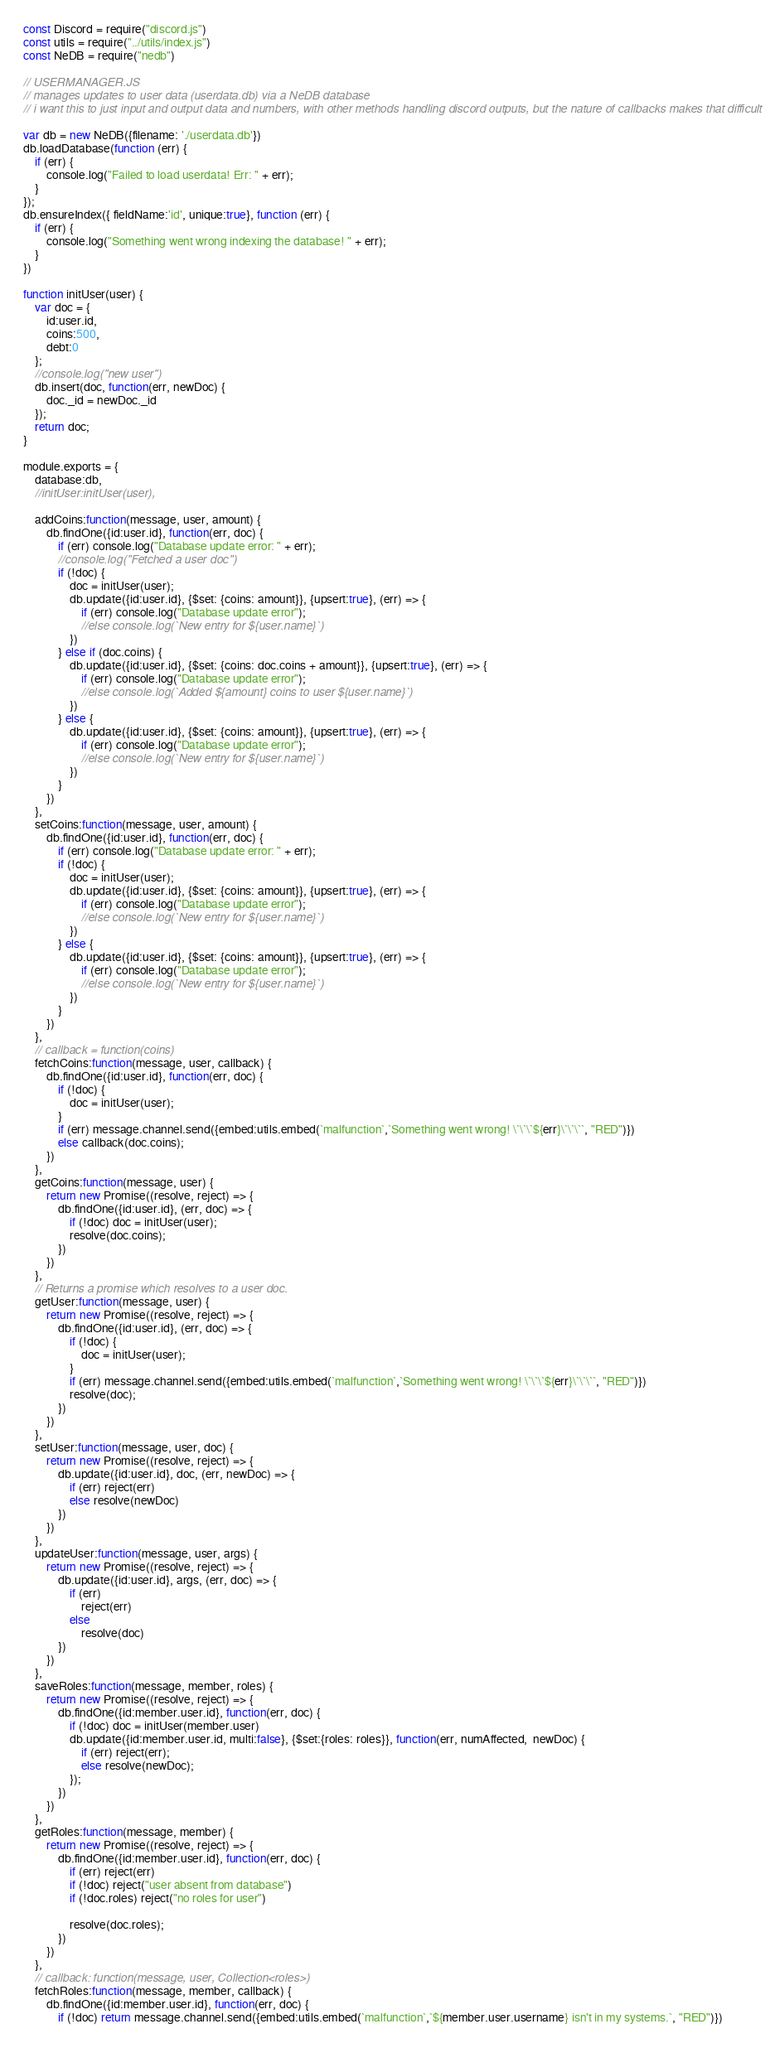Convert code to text. <code><loc_0><loc_0><loc_500><loc_500><_JavaScript_>const Discord = require("discord.js")
const utils = require("../utils/index.js")
const NeDB = require("nedb")

// USERMANAGER.JS
// manages updates to user data (userdata.db) via a NeDB database
// i want this to just input and output data and numbers, with other methods handling discord outputs, but the nature of callbacks makes that difficult

var db = new NeDB({filename: './userdata.db'})
db.loadDatabase(function (err) {
	if (err) {
		console.log("Failed to load userdata! Err: " + err);
	}
});
db.ensureIndex({ fieldName:'id', unique:true}, function (err) {
	if (err) {
		console.log("Something went wrong indexing the database! " + err);
	}
})

function initUser(user) {
	var doc = {
		id:user.id,
		coins:500,
		debt:0
	};
	//console.log("new user")
	db.insert(doc, function(err, newDoc) {
		doc._id = newDoc._id
	});
	return doc;
}

module.exports = {
	database:db,
	//initUser:initUser(user),

	addCoins:function(message, user, amount) {
		db.findOne({id:user.id}, function(err, doc) {
			if (err) console.log("Database update error: " + err);
			//console.log("Fetched a user doc")
			if (!doc) {
				doc = initUser(user);
				db.update({id:user.id}, {$set: {coins: amount}}, {upsert:true}, (err) => {
					if (err) console.log("Database update error");
					//else console.log(`New entry for ${user.name}`)
				})
			} else if (doc.coins) {
				db.update({id:user.id}, {$set: {coins: doc.coins + amount}}, {upsert:true}, (err) => {
					if (err) console.log("Database update error");
					//else console.log(`Added ${amount} coins to user ${user.name}`)
				})
			} else {
				db.update({id:user.id}, {$set: {coins: amount}}, {upsert:true}, (err) => {
					if (err) console.log("Database update error");
					//else console.log(`New entry for ${user.name}`)
				})
			}
		})
	},
	setCoins:function(message, user, amount) {
		db.findOne({id:user.id}, function(err, doc) {
			if (err) console.log("Database update error: " + err);
			if (!doc) {
				doc = initUser(user);
				db.update({id:user.id}, {$set: {coins: amount}}, {upsert:true}, (err) => {
					if (err) console.log("Database update error");
					//else console.log(`New entry for ${user.name}`)
				})
			} else {
				db.update({id:user.id}, {$set: {coins: amount}}, {upsert:true}, (err) => {
					if (err) console.log("Database update error");
					//else console.log(`New entry for ${user.name}`)
				})
			}
		})
	},
	// callback = function(coins)
	fetchCoins:function(message, user, callback) {
		db.findOne({id:user.id}, function(err, doc) {
			if (!doc) {
				doc = initUser(user);
			}
			if (err) message.channel.send({embed:utils.embed(`malfunction`,`Something went wrong! \`\`\`${err}\`\`\``, "RED")})
			else callback(doc.coins);
		})
	},
	getCoins:function(message, user) {
		return new Promise((resolve, reject) => {
			db.findOne({id:user.id}, (err, doc) => {
				if (!doc) doc = initUser(user);
				resolve(doc.coins);
			})
		})
	},
	// Returns a promise which resolves to a user doc.
	getUser:function(message, user) {
		return new Promise((resolve, reject) => {
			db.findOne({id:user.id}, (err, doc) => {
				if (!doc) {
					doc = initUser(user);
				}
				if (err) message.channel.send({embed:utils.embed(`malfunction`,`Something went wrong! \`\`\`${err}\`\`\``, "RED")})
				resolve(doc);
			})
		})
	},
	setUser:function(message, user, doc) {
		return new Promise((resolve, reject) => {
			db.update({id:user.id}, doc, (err, newDoc) => {
				if (err) reject(err)
				else resolve(newDoc)
			})
		})
	},
	updateUser:function(message, user, args) {
		return new Promise((resolve, reject) => {
			db.update({id:user.id}, args, (err, doc) => {
				if (err) 
					reject(err)
				else 
					resolve(doc)
			})
		})
	},
	saveRoles:function(message, member, roles) {
		return new Promise((resolve, reject) => {
			db.findOne({id:member.user.id}, function(err, doc) {
				if (!doc) doc = initUser(member.user)
				db.update({id:member.user.id, multi:false}, {$set:{roles: roles}}, function(err, numAffected,  newDoc) {
					if (err) reject(err);
					else resolve(newDoc);
				});
			})
		})
	},
	getRoles:function(message, member) {
		return new Promise((resolve, reject) => {
			db.findOne({id:member.user.id}, function(err, doc) {
				if (err) reject(err)
				if (!doc) reject("user absent from database")
				if (!doc.roles) reject("no roles for user")

				resolve(doc.roles);
			})
		})
	},
	// callback: function(message, user, Collection<roles>)
	fetchRoles:function(message, member, callback) {
		db.findOne({id:member.user.id}, function(err, doc) {
			if (!doc) return message.channel.send({embed:utils.embed(`malfunction`,`${member.user.username} isn't in my systems.`, "RED")})</code> 